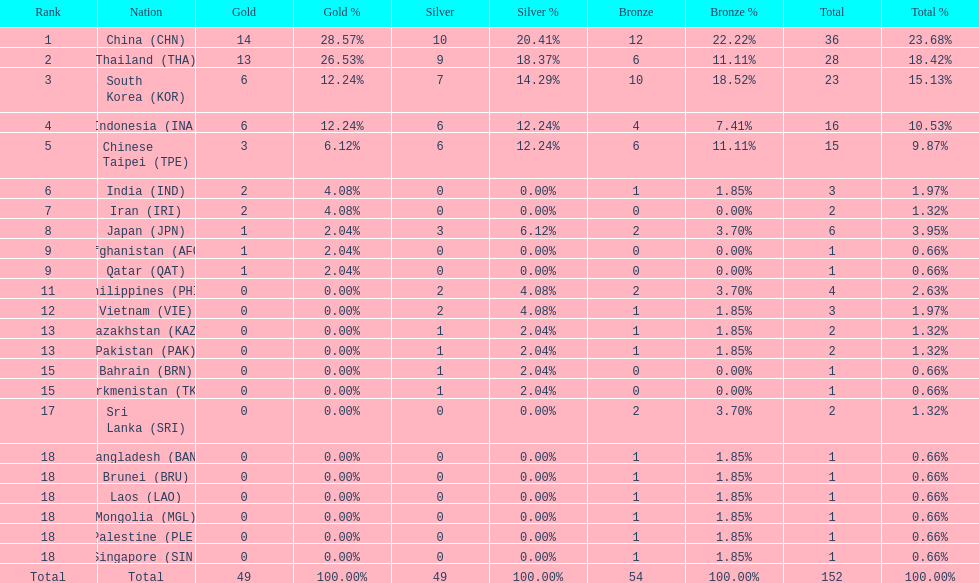How many total gold medal have been given? 49. 